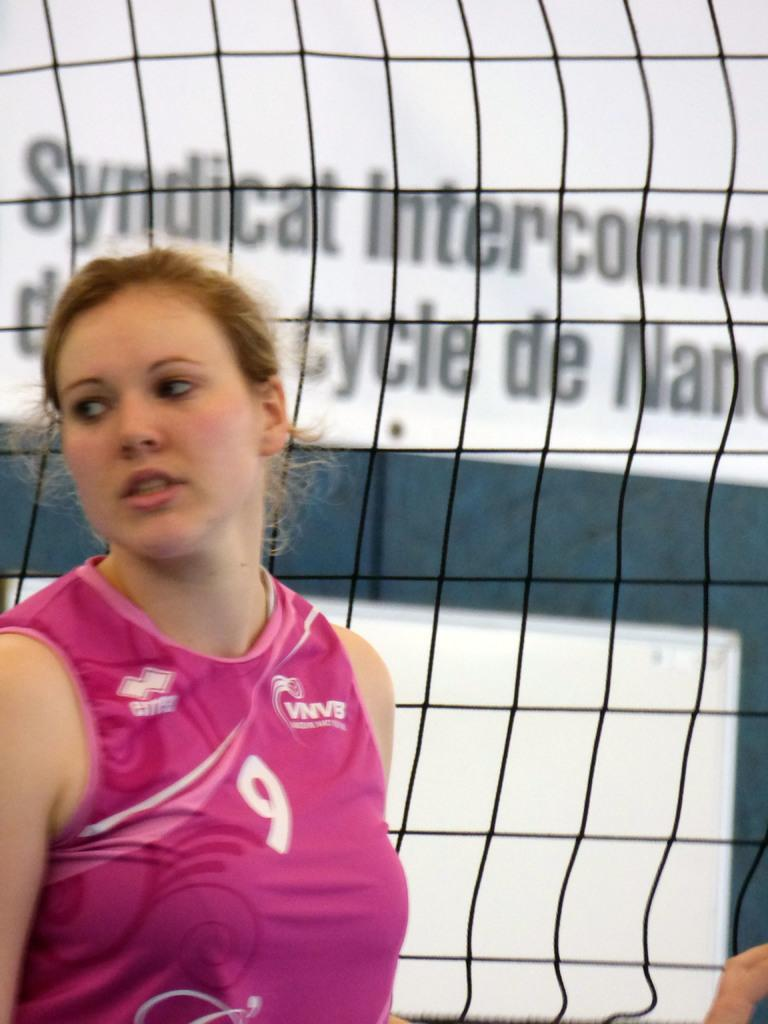Provide a one-sentence caption for the provided image. A Syndicat Intercommunal athlete stands near the net. 